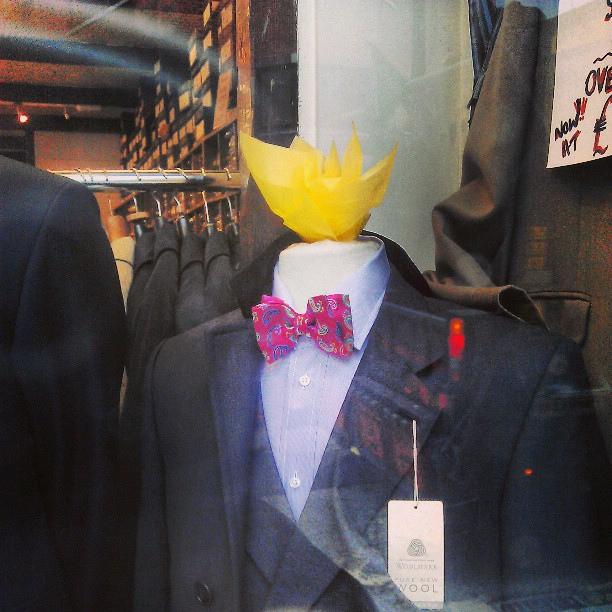Is there a price tag on the coast?
Short answer required. Yes. Is the coat featured double-breasted?
Be succinct. Yes. What color is the bow tie?
Write a very short answer. Pink. 